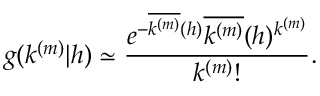Convert formula to latex. <formula><loc_0><loc_0><loc_500><loc_500>g ( k ^ { ( m ) } | h ) \simeq \frac { e ^ { - \overline { { k ^ { ( m ) } } } ( h ) } \overline { { k ^ { ( m ) } } } ( h ) ^ { k ^ { ( m ) } } } { k ^ { ( m ) } ! } .</formula> 